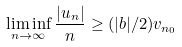Convert formula to latex. <formula><loc_0><loc_0><loc_500><loc_500>\liminf _ { n \rightarrow \infty } \frac { | u _ { n } | } { n } \geq ( | b | / 2 ) v _ { n _ { 0 } }</formula> 